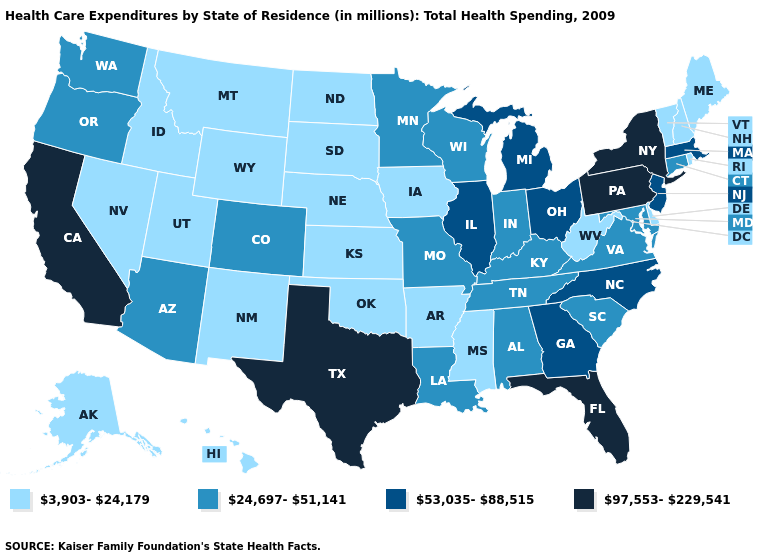What is the value of Nevada?
Answer briefly. 3,903-24,179. Among the states that border West Virginia , does Kentucky have the lowest value?
Answer briefly. Yes. Name the states that have a value in the range 3,903-24,179?
Write a very short answer. Alaska, Arkansas, Delaware, Hawaii, Idaho, Iowa, Kansas, Maine, Mississippi, Montana, Nebraska, Nevada, New Hampshire, New Mexico, North Dakota, Oklahoma, Rhode Island, South Dakota, Utah, Vermont, West Virginia, Wyoming. Does Illinois have a lower value than Indiana?
Give a very brief answer. No. What is the lowest value in the USA?
Write a very short answer. 3,903-24,179. What is the highest value in states that border Idaho?
Short answer required. 24,697-51,141. Which states have the lowest value in the Northeast?
Keep it brief. Maine, New Hampshire, Rhode Island, Vermont. Which states have the lowest value in the MidWest?
Write a very short answer. Iowa, Kansas, Nebraska, North Dakota, South Dakota. Does the map have missing data?
Quick response, please. No. Among the states that border Ohio , does Pennsylvania have the highest value?
Short answer required. Yes. Is the legend a continuous bar?
Quick response, please. No. What is the lowest value in states that border Missouri?
Quick response, please. 3,903-24,179. Does the first symbol in the legend represent the smallest category?
Keep it brief. Yes. Is the legend a continuous bar?
Quick response, please. No. Name the states that have a value in the range 97,553-229,541?
Be succinct. California, Florida, New York, Pennsylvania, Texas. 